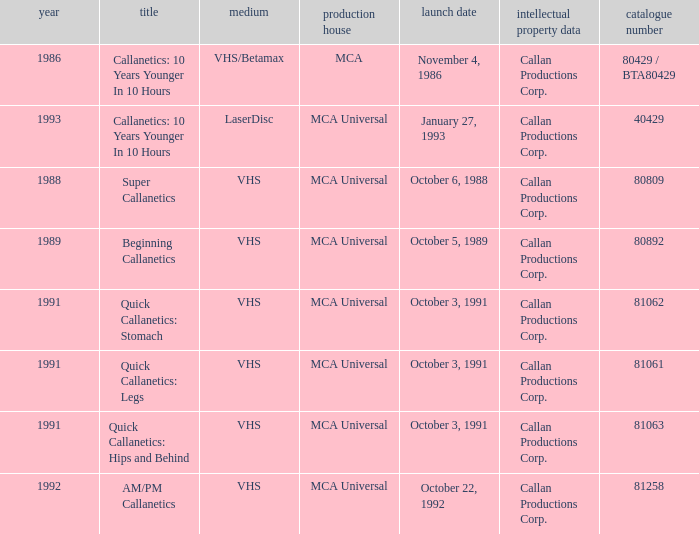Name the format for  quick callanetics: hips and behind VHS. 